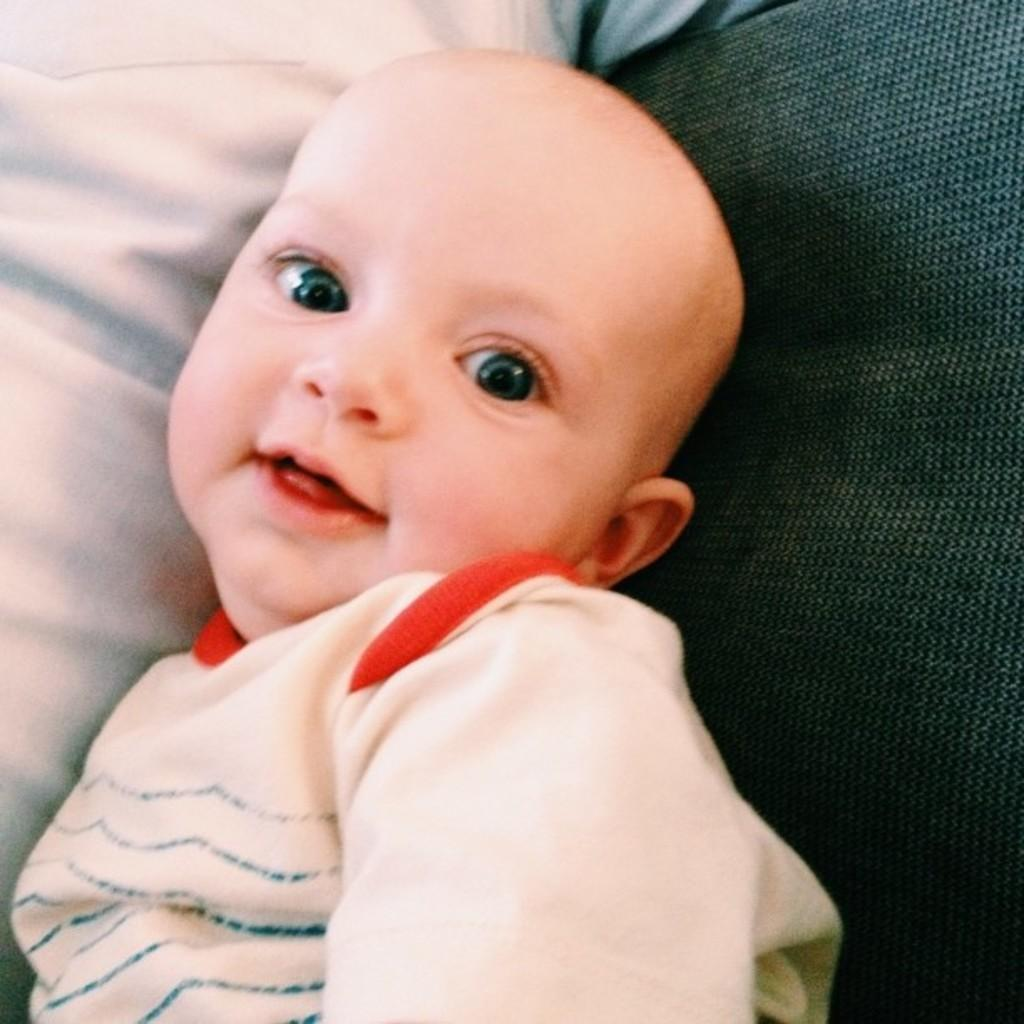What is the main subject of the image? There is a baby in the center of the image. Can you describe the baby's position or activity in the image? The facts provided do not specify the baby's position or activity. What else can be seen in the image besides the baby? There might be clothes in the background of the image. What type of shoes is the baby wearing in the image? There is no mention of shoes in the image, as the facts provided only mention the baby and the possible presence of clothes in the background. 